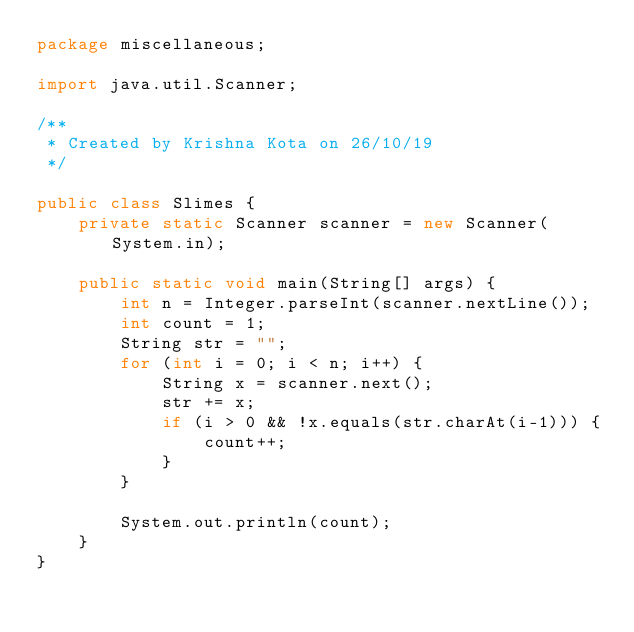<code> <loc_0><loc_0><loc_500><loc_500><_Java_>package miscellaneous;

import java.util.Scanner;

/**
 * Created by Krishna Kota on 26/10/19
 */

public class Slimes {
    private static Scanner scanner = new Scanner(System.in);

    public static void main(String[] args) {
        int n = Integer.parseInt(scanner.nextLine());
        int count = 1;
        String str = "";
        for (int i = 0; i < n; i++) {
            String x = scanner.next();
            str += x;
            if (i > 0 && !x.equals(str.charAt(i-1))) {
                count++;
            }
        }
        
        System.out.println(count);
    }
}
</code> 